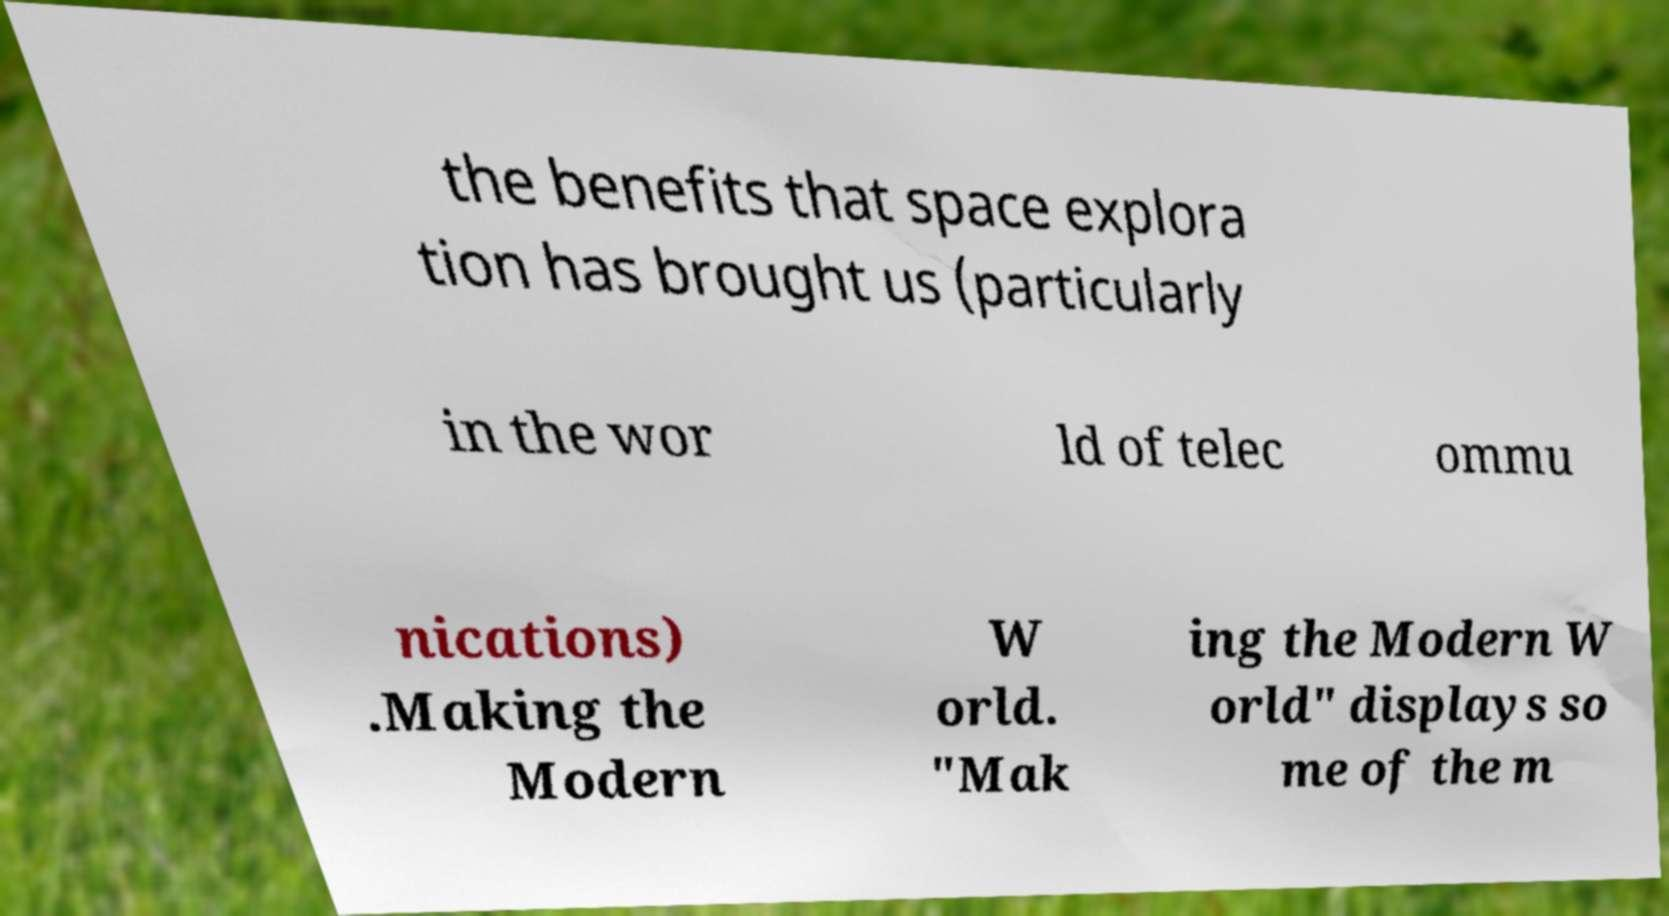What messages or text are displayed in this image? I need them in a readable, typed format. the benefits that space explora tion has brought us (particularly in the wor ld of telec ommu nications) .Making the Modern W orld. "Mak ing the Modern W orld" displays so me of the m 